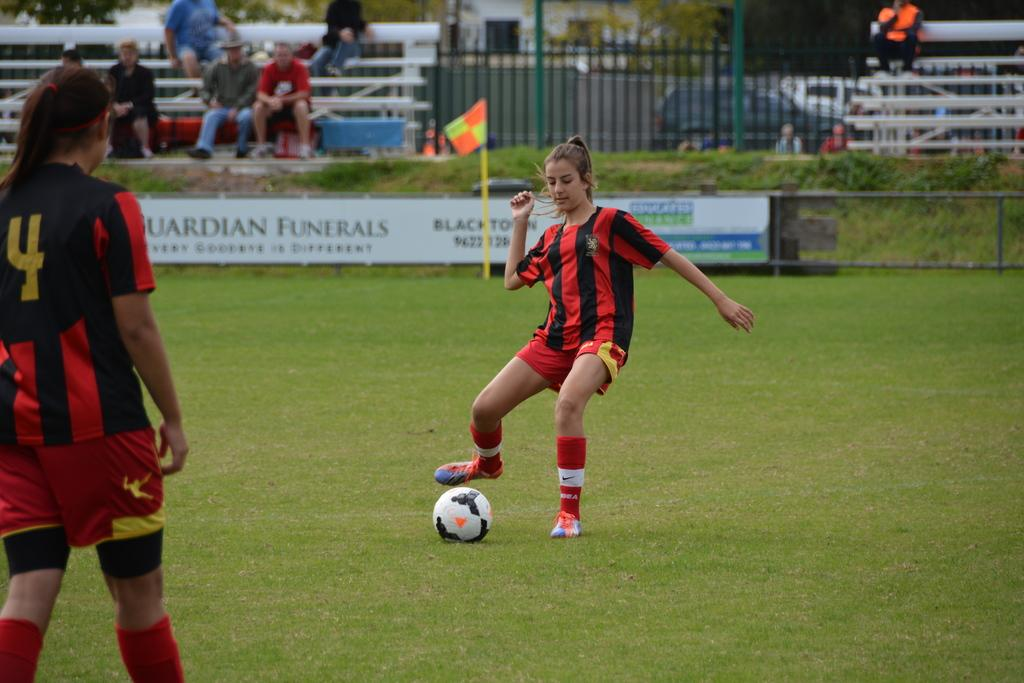<image>
Provide a brief description of the given image. a soccer field with a sign on the sidelines that says 'guardian funerals' 